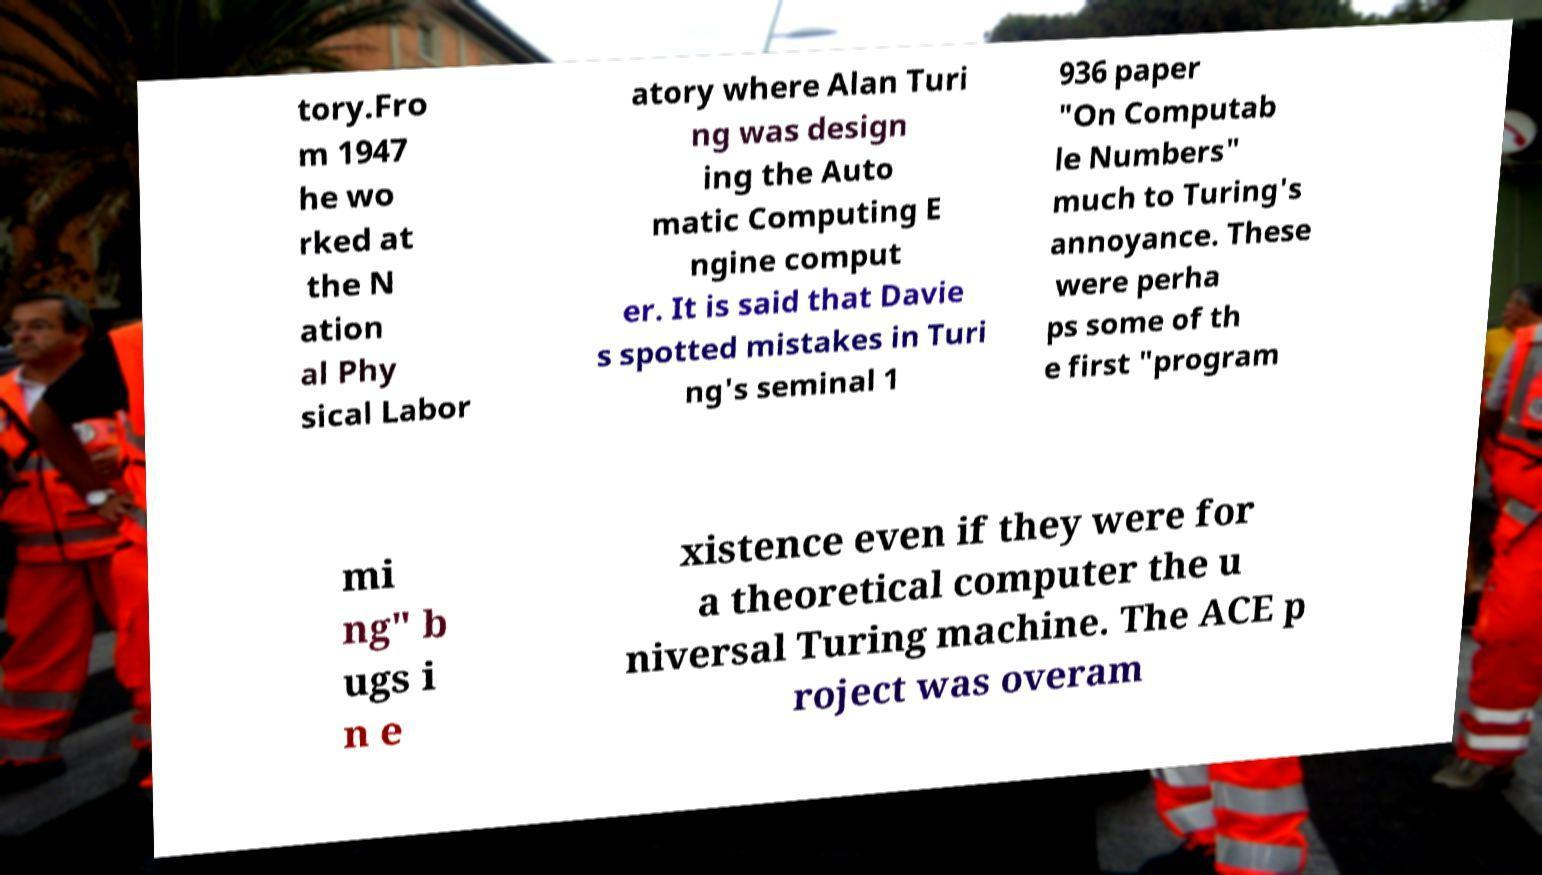Please read and relay the text visible in this image. What does it say? tory.Fro m 1947 he wo rked at the N ation al Phy sical Labor atory where Alan Turi ng was design ing the Auto matic Computing E ngine comput er. It is said that Davie s spotted mistakes in Turi ng's seminal 1 936 paper "On Computab le Numbers" much to Turing's annoyance. These were perha ps some of th e first "program mi ng" b ugs i n e xistence even if they were for a theoretical computer the u niversal Turing machine. The ACE p roject was overam 